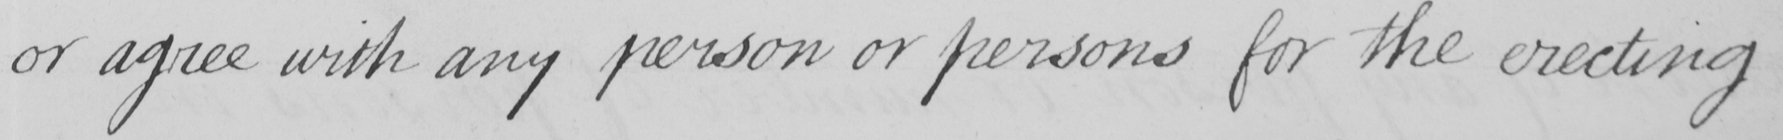What does this handwritten line say? or agree with any person or persons for the erecting 